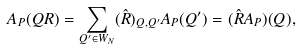Convert formula to latex. <formula><loc_0><loc_0><loc_500><loc_500>A _ { P } ( Q R ) = \sum _ { Q ^ { \prime } \in W _ { N } } ( \hat { R } ) _ { Q , Q ^ { \prime } } A _ { P } ( Q ^ { \prime } ) = ( \hat { R } A _ { P } ) ( Q ) ,</formula> 